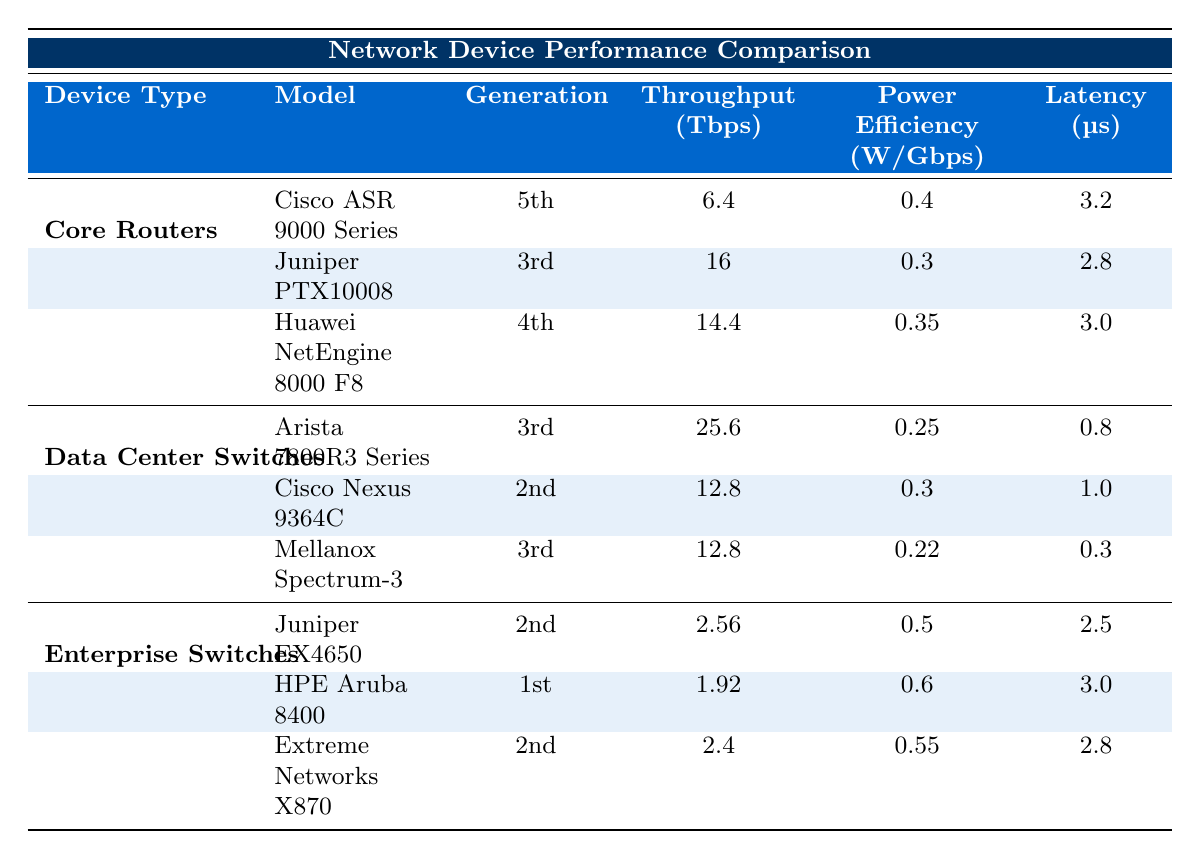What is the throughput of the Juniper PTX10008 model? The throughput of the Juniper PTX10008 model is listed in the table, and it specifically states 16 Tbps.
Answer: 16 Tbps Which enterprise switch has the highest power efficiency? In the Enterprise Switches section, the power efficiency values for Juniper EX4650, HPE Aruba 8400, and Extreme Networks X870 are 0.5, 0.6, and 0.55 W/Gbps respectively. Comparing these, HPE Aruba 8400 has the highest at 0.6 W/Gbps.
Answer: HPE Aruba 8400 What is the average latency of all Core Routers? The latencies of Core Routers are 3.2 µs (Cisco ASR 9000 Series), 2.8 µs (Juniper PTX10008), and 3.0 µs (Huawei NetEngine 8000 F8). Adding these: 3.2 + 2.8 + 3.0 = 9 µs, then dividing by 3 gives an average latency of 3.0 µs.
Answer: 3.0 µs Is the throughput of Arista 7800R3 Series greater than that of Cisco Nexus 9364C? The throughput of Arista 7800R3 Series is 25.6 Tbps and Cisco Nexus 9364C is 12.8 Tbps. Since 25.6 is greater than 12.8, the statement is true.
Answer: Yes Which Data Center Switch has the lowest latency, and what is that latency? The latencies for Data Center Switches are 0.8 µs (Arista 7800R3 Series), 1.0 µs (Cisco Nexus 9364C), and 0.3 µs (Mellanox Spectrum-3). Comparing these values, the lowest latency is 0.3 µs for Mellanox Spectrum-3.
Answer: Mellanox Spectrum-3, 0.3 µs Calculate the total throughput of all the devices listed in the Enterprise Switches section. The throughput values for the Enterprise Switches are 2.56 Tbps (Juniper EX4650), 1.92 Tbps (HPE Aruba 8400), and 2.4 Tbps (Extreme Networks X870). Adding these gives: 2.56 + 1.92 + 2.4 = 6.88 Tbps.
Answer: 6.88 Tbps Which Core Router has the best power efficiency? The power efficiencies for Core Routers are 0.4 W/Gbps (Cisco ASR 9000 Series), 0.3 W/Gbps (Juniper PTX10008), and 0.35 W/Gbps (Huawei NetEngine 8000 F8). The best power efficiency is 0.3 W/Gbps for Juniper PTX10008 as it is the lowest value.
Answer: Juniper PTX10008 What is the total number of ports available for the Cisco Nexus 9364C? The Cisco Nexus 9364C is listed to have ports of 100GbE only. Since it is a single entry, the total number of ports is simply the number indicated: 100GbE.
Answer: 100GbE 